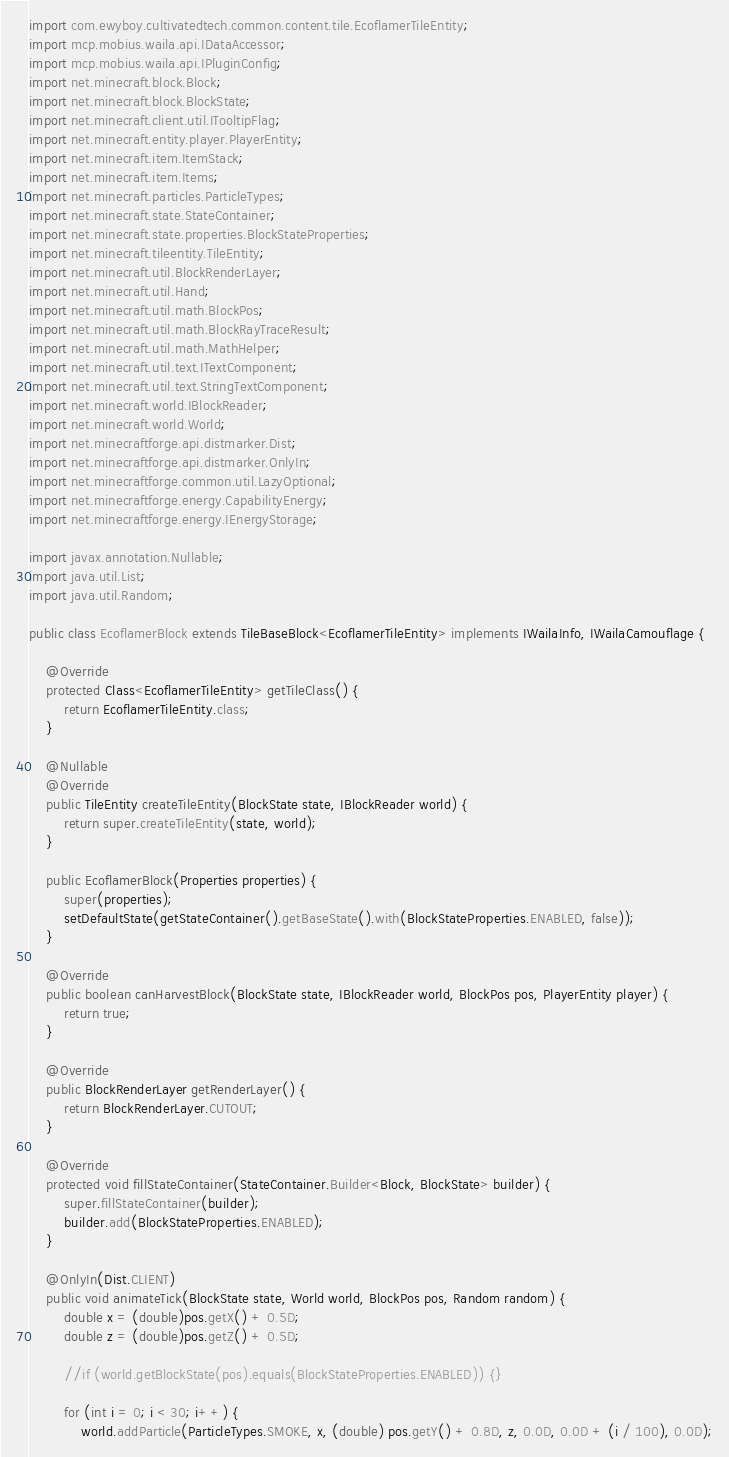<code> <loc_0><loc_0><loc_500><loc_500><_Java_>import com.ewyboy.cultivatedtech.common.content.tile.EcoflamerTileEntity;
import mcp.mobius.waila.api.IDataAccessor;
import mcp.mobius.waila.api.IPluginConfig;
import net.minecraft.block.Block;
import net.minecraft.block.BlockState;
import net.minecraft.client.util.ITooltipFlag;
import net.minecraft.entity.player.PlayerEntity;
import net.minecraft.item.ItemStack;
import net.minecraft.item.Items;
import net.minecraft.particles.ParticleTypes;
import net.minecraft.state.StateContainer;
import net.minecraft.state.properties.BlockStateProperties;
import net.minecraft.tileentity.TileEntity;
import net.minecraft.util.BlockRenderLayer;
import net.minecraft.util.Hand;
import net.minecraft.util.math.BlockPos;
import net.minecraft.util.math.BlockRayTraceResult;
import net.minecraft.util.math.MathHelper;
import net.minecraft.util.text.ITextComponent;
import net.minecraft.util.text.StringTextComponent;
import net.minecraft.world.IBlockReader;
import net.minecraft.world.World;
import net.minecraftforge.api.distmarker.Dist;
import net.minecraftforge.api.distmarker.OnlyIn;
import net.minecraftforge.common.util.LazyOptional;
import net.minecraftforge.energy.CapabilityEnergy;
import net.minecraftforge.energy.IEnergyStorage;

import javax.annotation.Nullable;
import java.util.List;
import java.util.Random;

public class EcoflamerBlock extends TileBaseBlock<EcoflamerTileEntity> implements IWailaInfo, IWailaCamouflage {

    @Override
    protected Class<EcoflamerTileEntity> getTileClass() {
        return EcoflamerTileEntity.class;
    }

    @Nullable
    @Override
    public TileEntity createTileEntity(BlockState state, IBlockReader world) {
        return super.createTileEntity(state, world);
    }

    public EcoflamerBlock(Properties properties) {
        super(properties);
        setDefaultState(getStateContainer().getBaseState().with(BlockStateProperties.ENABLED, false));
    }

    @Override
    public boolean canHarvestBlock(BlockState state, IBlockReader world, BlockPos pos, PlayerEntity player) {
        return true;
    }

    @Override
    public BlockRenderLayer getRenderLayer() {
        return BlockRenderLayer.CUTOUT;
    }

    @Override
    protected void fillStateContainer(StateContainer.Builder<Block, BlockState> builder) {
        super.fillStateContainer(builder);
        builder.add(BlockStateProperties.ENABLED);
    }

    @OnlyIn(Dist.CLIENT)
    public void animateTick(BlockState state, World world, BlockPos pos, Random random) {
        double x = (double)pos.getX() + 0.5D;
        double z = (double)pos.getZ() + 0.5D;

        //if (world.getBlockState(pos).equals(BlockStateProperties.ENABLED)) {}

        for (int i = 0; i < 30; i++) {
            world.addParticle(ParticleTypes.SMOKE, x, (double) pos.getY() + 0.8D, z, 0.0D, 0.0D + (i / 100), 0.0D);</code> 